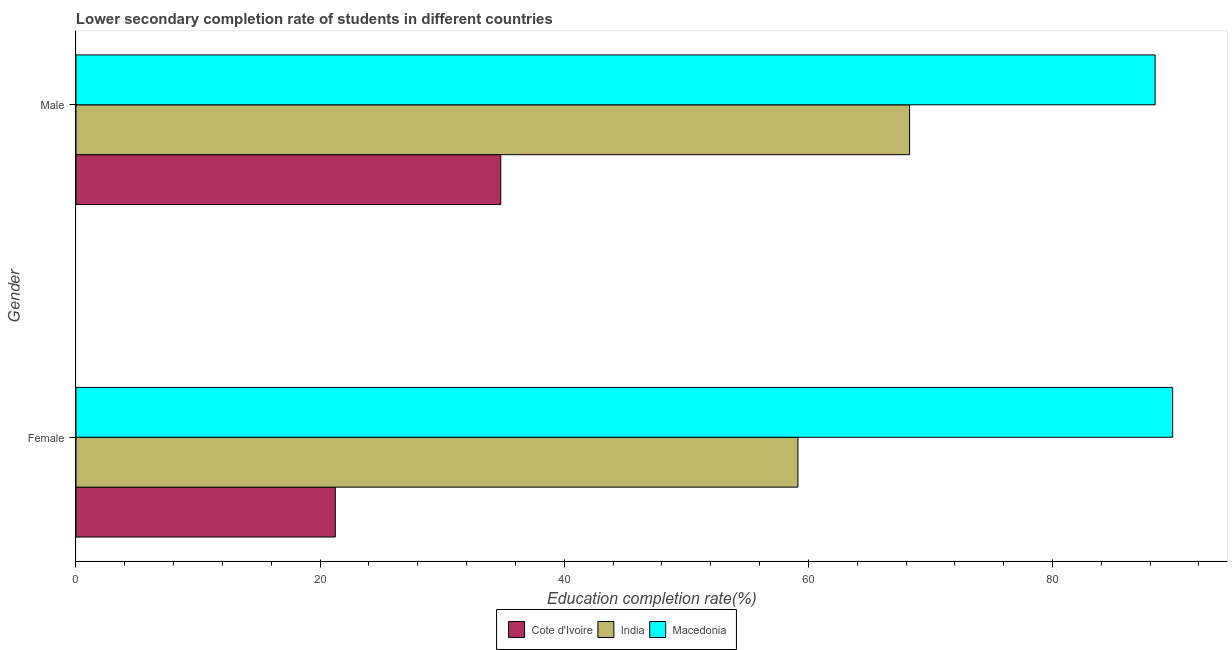Are the number of bars per tick equal to the number of legend labels?
Keep it short and to the point. Yes. Are the number of bars on each tick of the Y-axis equal?
Your answer should be very brief. Yes. How many bars are there on the 1st tick from the top?
Provide a succinct answer. 3. What is the label of the 1st group of bars from the top?
Keep it short and to the point. Male. What is the education completion rate of female students in Cote d'Ivoire?
Provide a short and direct response. 21.24. Across all countries, what is the maximum education completion rate of female students?
Provide a succinct answer. 89.84. Across all countries, what is the minimum education completion rate of female students?
Provide a succinct answer. 21.24. In which country was the education completion rate of male students maximum?
Your answer should be very brief. Macedonia. In which country was the education completion rate of male students minimum?
Provide a short and direct response. Cote d'Ivoire. What is the total education completion rate of male students in the graph?
Provide a succinct answer. 191.5. What is the difference between the education completion rate of female students in India and that in Macedonia?
Keep it short and to the point. -30.7. What is the difference between the education completion rate of female students in Cote d'Ivoire and the education completion rate of male students in India?
Make the answer very short. -47.05. What is the average education completion rate of male students per country?
Ensure brevity in your answer.  63.83. What is the difference between the education completion rate of female students and education completion rate of male students in Cote d'Ivoire?
Provide a short and direct response. -13.55. What is the ratio of the education completion rate of male students in India to that in Cote d'Ivoire?
Ensure brevity in your answer.  1.96. Is the education completion rate of male students in Cote d'Ivoire less than that in India?
Make the answer very short. Yes. In how many countries, is the education completion rate of male students greater than the average education completion rate of male students taken over all countries?
Your response must be concise. 2. What does the 3rd bar from the top in Female represents?
Offer a terse response. Cote d'Ivoire. What does the 1st bar from the bottom in Male represents?
Provide a short and direct response. Cote d'Ivoire. How many bars are there?
Make the answer very short. 6. Are all the bars in the graph horizontal?
Keep it short and to the point. Yes. Are the values on the major ticks of X-axis written in scientific E-notation?
Your answer should be very brief. No. Does the graph contain any zero values?
Give a very brief answer. No. Where does the legend appear in the graph?
Your response must be concise. Bottom center. What is the title of the graph?
Your answer should be compact. Lower secondary completion rate of students in different countries. Does "Serbia" appear as one of the legend labels in the graph?
Your response must be concise. No. What is the label or title of the X-axis?
Your response must be concise. Education completion rate(%). What is the label or title of the Y-axis?
Your answer should be compact. Gender. What is the Education completion rate(%) of Cote d'Ivoire in Female?
Your answer should be very brief. 21.24. What is the Education completion rate(%) in India in Female?
Offer a very short reply. 59.14. What is the Education completion rate(%) of Macedonia in Female?
Your answer should be compact. 89.84. What is the Education completion rate(%) in Cote d'Ivoire in Male?
Give a very brief answer. 34.8. What is the Education completion rate(%) in India in Male?
Give a very brief answer. 68.29. What is the Education completion rate(%) in Macedonia in Male?
Provide a short and direct response. 88.41. Across all Gender, what is the maximum Education completion rate(%) of Cote d'Ivoire?
Keep it short and to the point. 34.8. Across all Gender, what is the maximum Education completion rate(%) in India?
Provide a short and direct response. 68.29. Across all Gender, what is the maximum Education completion rate(%) in Macedonia?
Provide a short and direct response. 89.84. Across all Gender, what is the minimum Education completion rate(%) in Cote d'Ivoire?
Ensure brevity in your answer.  21.24. Across all Gender, what is the minimum Education completion rate(%) in India?
Offer a terse response. 59.14. Across all Gender, what is the minimum Education completion rate(%) of Macedonia?
Give a very brief answer. 88.41. What is the total Education completion rate(%) of Cote d'Ivoire in the graph?
Ensure brevity in your answer.  56.04. What is the total Education completion rate(%) in India in the graph?
Make the answer very short. 127.44. What is the total Education completion rate(%) in Macedonia in the graph?
Offer a very short reply. 178.25. What is the difference between the Education completion rate(%) of Cote d'Ivoire in Female and that in Male?
Offer a very short reply. -13.55. What is the difference between the Education completion rate(%) of India in Female and that in Male?
Keep it short and to the point. -9.15. What is the difference between the Education completion rate(%) of Macedonia in Female and that in Male?
Give a very brief answer. 1.44. What is the difference between the Education completion rate(%) in Cote d'Ivoire in Female and the Education completion rate(%) in India in Male?
Your answer should be very brief. -47.05. What is the difference between the Education completion rate(%) in Cote d'Ivoire in Female and the Education completion rate(%) in Macedonia in Male?
Offer a terse response. -67.16. What is the difference between the Education completion rate(%) of India in Female and the Education completion rate(%) of Macedonia in Male?
Your response must be concise. -29.26. What is the average Education completion rate(%) of Cote d'Ivoire per Gender?
Offer a very short reply. 28.02. What is the average Education completion rate(%) in India per Gender?
Keep it short and to the point. 63.72. What is the average Education completion rate(%) in Macedonia per Gender?
Offer a very short reply. 89.13. What is the difference between the Education completion rate(%) in Cote d'Ivoire and Education completion rate(%) in India in Female?
Give a very brief answer. -37.9. What is the difference between the Education completion rate(%) of Cote d'Ivoire and Education completion rate(%) of Macedonia in Female?
Your response must be concise. -68.6. What is the difference between the Education completion rate(%) in India and Education completion rate(%) in Macedonia in Female?
Ensure brevity in your answer.  -30.7. What is the difference between the Education completion rate(%) in Cote d'Ivoire and Education completion rate(%) in India in Male?
Give a very brief answer. -33.5. What is the difference between the Education completion rate(%) in Cote d'Ivoire and Education completion rate(%) in Macedonia in Male?
Provide a short and direct response. -53.61. What is the difference between the Education completion rate(%) of India and Education completion rate(%) of Macedonia in Male?
Provide a short and direct response. -20.11. What is the ratio of the Education completion rate(%) of Cote d'Ivoire in Female to that in Male?
Provide a succinct answer. 0.61. What is the ratio of the Education completion rate(%) of India in Female to that in Male?
Your answer should be very brief. 0.87. What is the ratio of the Education completion rate(%) in Macedonia in Female to that in Male?
Offer a terse response. 1.02. What is the difference between the highest and the second highest Education completion rate(%) of Cote d'Ivoire?
Keep it short and to the point. 13.55. What is the difference between the highest and the second highest Education completion rate(%) in India?
Ensure brevity in your answer.  9.15. What is the difference between the highest and the second highest Education completion rate(%) in Macedonia?
Your response must be concise. 1.44. What is the difference between the highest and the lowest Education completion rate(%) in Cote d'Ivoire?
Your answer should be very brief. 13.55. What is the difference between the highest and the lowest Education completion rate(%) of India?
Ensure brevity in your answer.  9.15. What is the difference between the highest and the lowest Education completion rate(%) of Macedonia?
Ensure brevity in your answer.  1.44. 